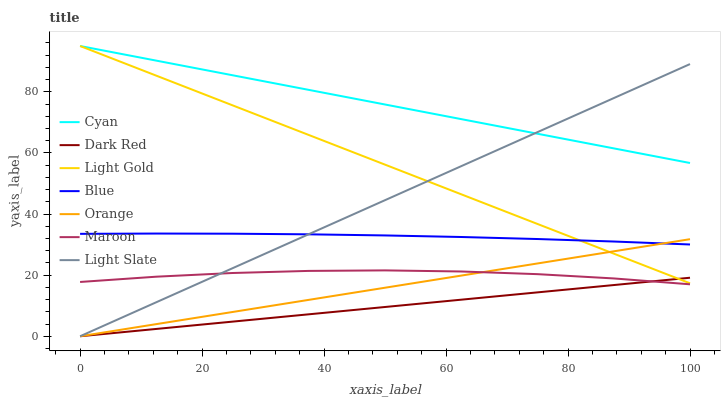Does Dark Red have the minimum area under the curve?
Answer yes or no. Yes. Does Cyan have the maximum area under the curve?
Answer yes or no. Yes. Does Light Slate have the minimum area under the curve?
Answer yes or no. No. Does Light Slate have the maximum area under the curve?
Answer yes or no. No. Is Dark Red the smoothest?
Answer yes or no. Yes. Is Maroon the roughest?
Answer yes or no. Yes. Is Light Slate the smoothest?
Answer yes or no. No. Is Light Slate the roughest?
Answer yes or no. No. Does Light Slate have the lowest value?
Answer yes or no. Yes. Does Maroon have the lowest value?
Answer yes or no. No. Does Light Gold have the highest value?
Answer yes or no. Yes. Does Light Slate have the highest value?
Answer yes or no. No. Is Dark Red less than Cyan?
Answer yes or no. Yes. Is Blue greater than Maroon?
Answer yes or no. Yes. Does Light Gold intersect Cyan?
Answer yes or no. Yes. Is Light Gold less than Cyan?
Answer yes or no. No. Is Light Gold greater than Cyan?
Answer yes or no. No. Does Dark Red intersect Cyan?
Answer yes or no. No. 